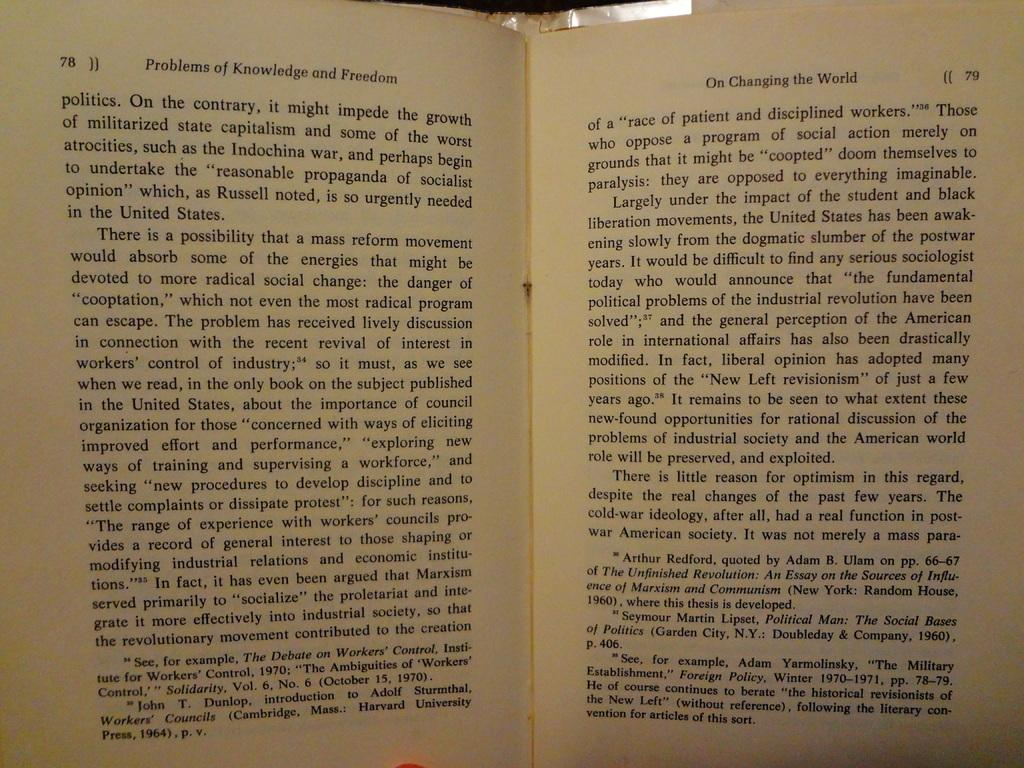<image>
Offer a succinct explanation of the picture presented. An open book showing two pages that are numbered 78 and 79. 